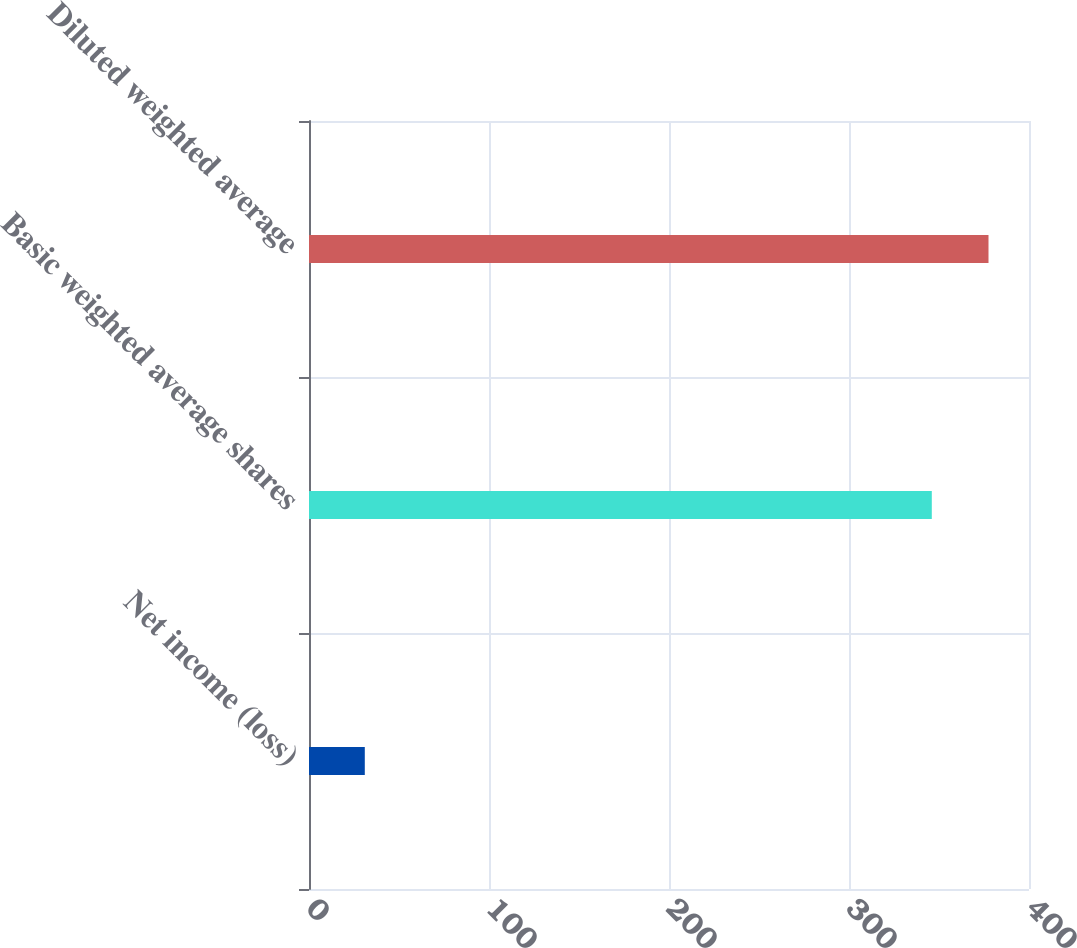Convert chart. <chart><loc_0><loc_0><loc_500><loc_500><bar_chart><fcel>Net income (loss)<fcel>Basic weighted average shares<fcel>Diluted weighted average<nl><fcel>31<fcel>346<fcel>377.5<nl></chart> 